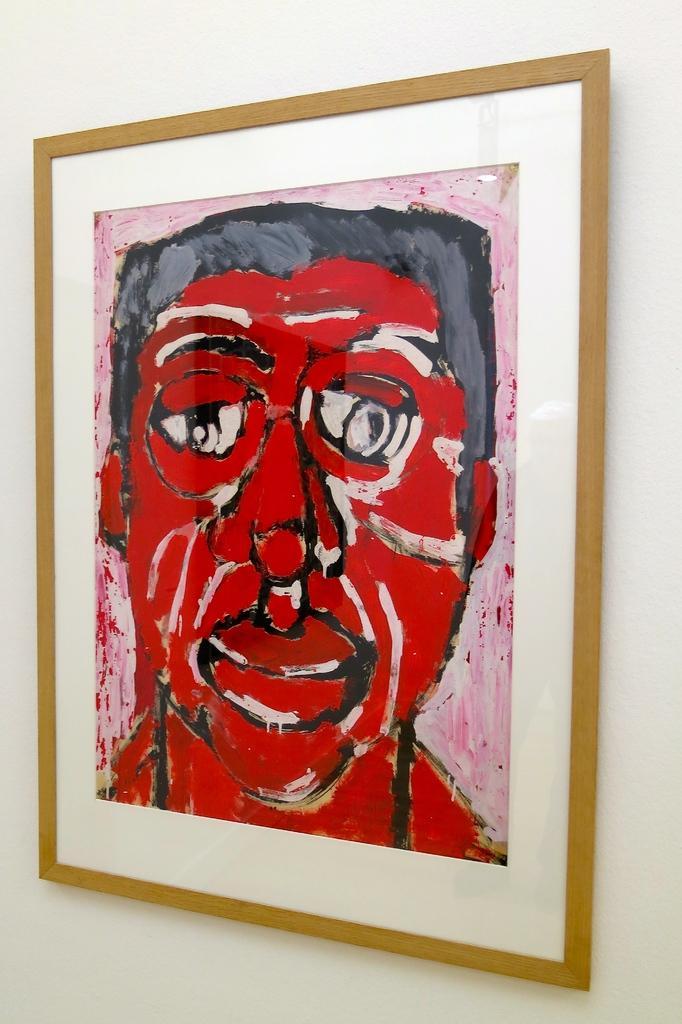How would you summarize this image in a sentence or two? In this picture there is a portrait in the center of the image, on which there is a man. 